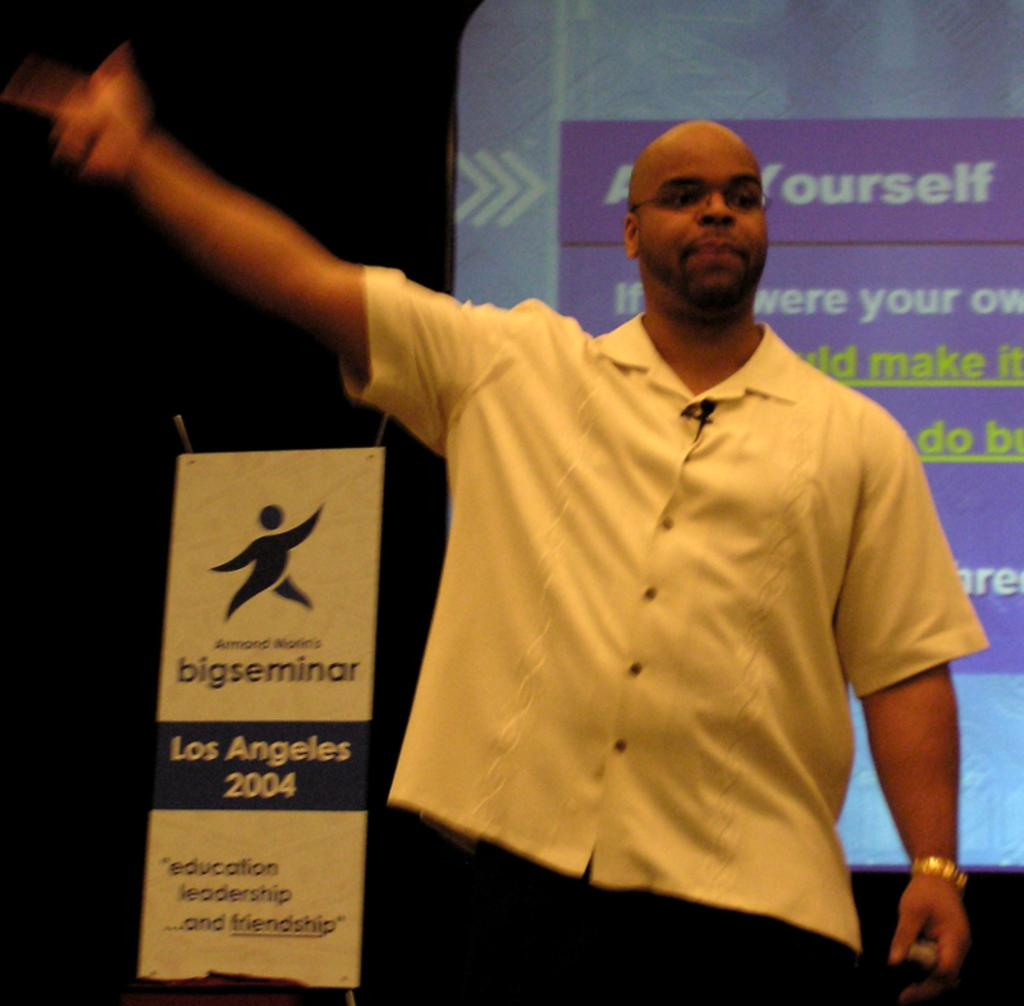What is the appearance of the man's hair in the image? The man in the image is bald-headed. What is the man wearing in the image? The man is wearing a white shirt. What is the man standing in front of in the image? The man is standing in front of a screen. What is visible behind the man in the image? There is a banner behind the man. Can you see any spots on the hill behind the man in the image? There is no hill present in the image; the man is standing in front of a screen with a banner behind him. 